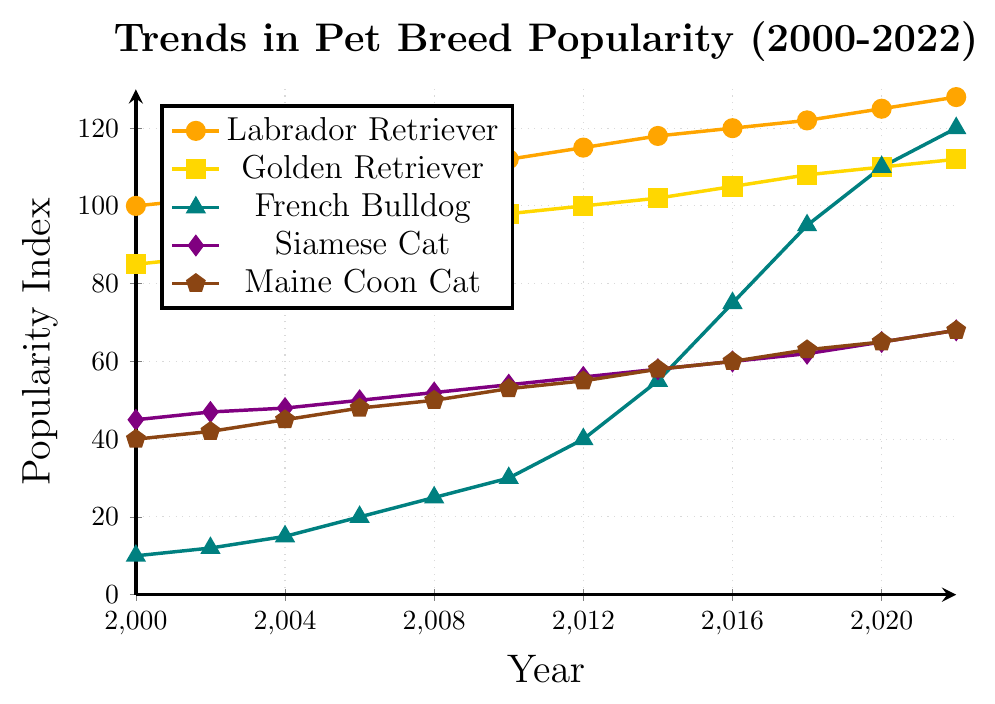Which pet breed showed the greatest increase in popularity from 2000 to 2022? To determine the pet breed with the greatest increase, look at the initial and final popularity indices for each breed in the specified timeframe and calculate the difference. The French Bulldog starts at 10 in 2000 and increases to 120 in 2022, a difference of 110, which is the greatest among all breeds.
Answer: French Bulldog Between the Labrador Retriever and Golden Retriever, which breed was more popular in 2010? Compare the popularity indices of the two breeds in 2010. The Labrador Retriever has a popularity index of 112, while the Golden Retriever has a popularity index of 98.
Answer: Labrador Retriever What is the average popularity of the Siamese Cat from 2000 to 2022? Sum the popularity indices for the Siamese Cat across all years and divide by the total number of years. The sum is 45 + 47 + 48 + 50 + 52 + 54 + 56 + 58 + 60 + 62 + 65 + 68 = 665. There are 12 years, so the average is 665 / 12 ≈ 55.42.
Answer: 55.42 Which breed had the smallest change in popularity from 2000 to 2022? Calculate the change in popularity for each breed by taking the difference between the 2022 and 2000 values: Labrador Retriever (128-100=28), Golden Retriever (112-85=27), French Bulldog (120-10=110), Siamese Cat (68-45=23), Maine Coon Cat (68-40=28). The Golden Retriever had the smallest change at 27.
Answer: Golden Retriever What is the total increase in popularity for all breeds combined from 2000 to 2022? Sum the changes in popularity for each breed. Labrador Retriever: 128-100=28, Golden Retriever: 112-85=27, French Bulldog: 120-10=110, Siamese Cat: 68-45=23, Maine Coon Cat: 68-40=28. Total increase = 28 + 27 + 110 + 23 + 28 = 216.
Answer: 216 In which year did the French Bulldog's popularity surpass the Golden Retriever's? Identify the year where the French Bulldog's popularity index first exceeds that of the Golden Retriever. This occurs in 2016, where the French Bulldog's index is 75, and the Golden Retriever's index is 105. By 2020, the French Bulldog's index reaches 110, surpassing the Golden Retriever's 110.
Answer: 2020 How did the popularity of the Maine Coon Cat change between 2006 and 2016? Find the popularity indices in 2006 and 2016 and calculate the difference. In 2006, the index was 48, and in 2016 it was 60. The change is 60-48 = 12.
Answer: Increased by 12 Compare the average popularity index of Labrador Retrievers and Golden Retrievers over all years. Which breed has a higher average? Calculate the average for both breeds over all years. Labrador Retriever: (100+102+105+108+110+112+115+118+120+122+125+128)/12 = 112.83; Golden Retriever: (85 + 87 + 90 + 92 + 95 + 98 + 100 + 102 + 105 + 108 + 110 + 112) / 12 ≈ 98.67. The Labrador Retriever has a higher average.
Answer: Labrador Retriever Which breed showed a steeper growth in popularity, French Bulldog or Siamese Cat, between 2014 and 2022? Determine the rate of change for both breeds in this timeframe. French Bulldog: (120-55) / (2022-2014) = 65 / 8 ≈ 8.13 per year. Siamese Cat: (68 - 58) / (2022 - 2014) = 10 / 8 = 1.25 per year. The French Bulldog had a steeper growth.
Answer: French Bulldog Which breed has generally shown a consistent upward trend without any decrease? Look for a steady increase without drops over the years. The Labrador Retriever's index steadily increases from 100 in 2000 to 128 in 2022 without any decreases in between.
Answer: Labrador Retriever 